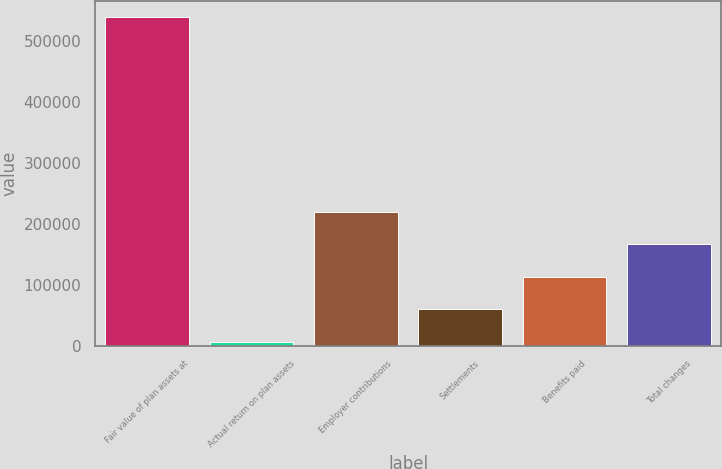Convert chart to OTSL. <chart><loc_0><loc_0><loc_500><loc_500><bar_chart><fcel>Fair value of plan assets at<fcel>Actual return on plan assets<fcel>Employer contributions<fcel>Settlements<fcel>Benefits paid<fcel>Total changes<nl><fcel>538970<fcel>6593<fcel>219544<fcel>59830.7<fcel>113068<fcel>166306<nl></chart> 